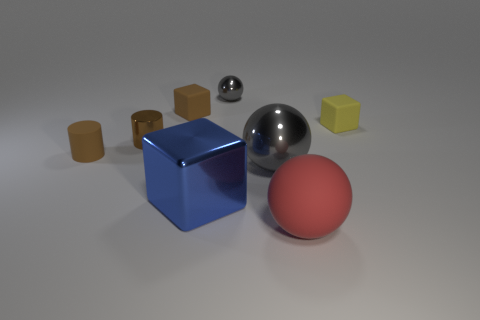Add 1 red spheres. How many objects exist? 9 Subtract all cubes. How many objects are left? 5 Add 1 gray rubber things. How many gray rubber things exist? 1 Subtract 0 yellow cylinders. How many objects are left? 8 Subtract all large rubber spheres. Subtract all large blue metal objects. How many objects are left? 6 Add 6 large blocks. How many large blocks are left? 7 